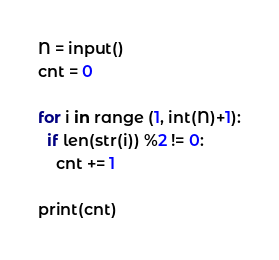<code> <loc_0><loc_0><loc_500><loc_500><_Python_>N = input()
cnt = 0

for i in range (1, int(N)+1):
  if len(str(i)) %2 != 0:
    cnt += 1
    
print(cnt)</code> 